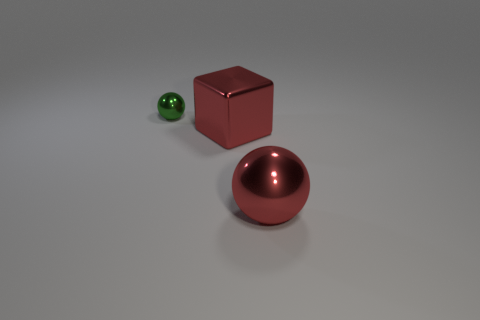Add 3 large purple shiny cubes. How many objects exist? 6 Subtract all spheres. How many objects are left? 1 Subtract 0 purple cubes. How many objects are left? 3 Subtract all big brown shiny cubes. Subtract all tiny green objects. How many objects are left? 2 Add 2 metal spheres. How many metal spheres are left? 4 Add 2 big gray balls. How many big gray balls exist? 2 